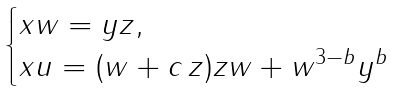Convert formula to latex. <formula><loc_0><loc_0><loc_500><loc_500>\begin{cases} x w = y z , \\ x u = ( w + c \, z ) z w + w ^ { 3 - b } y ^ { b } \end{cases}</formula> 